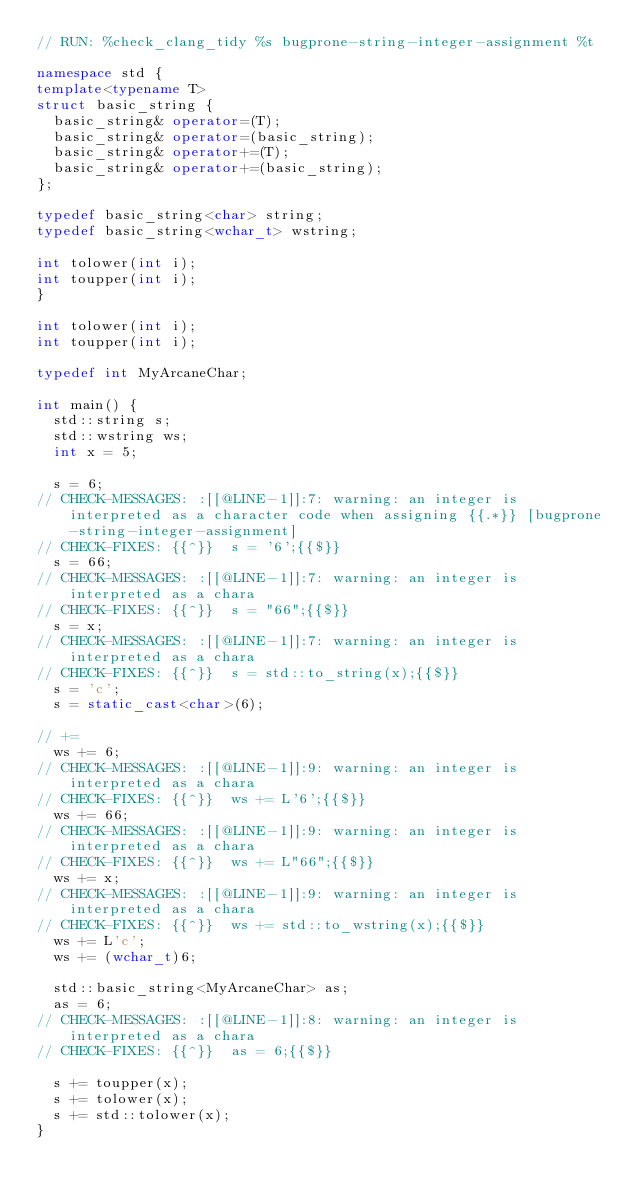Convert code to text. <code><loc_0><loc_0><loc_500><loc_500><_C++_>// RUN: %check_clang_tidy %s bugprone-string-integer-assignment %t

namespace std {
template<typename T>
struct basic_string {
  basic_string& operator=(T);
  basic_string& operator=(basic_string);
  basic_string& operator+=(T);
  basic_string& operator+=(basic_string);
};

typedef basic_string<char> string;
typedef basic_string<wchar_t> wstring;

int tolower(int i);
int toupper(int i);
}

int tolower(int i);
int toupper(int i);

typedef int MyArcaneChar;

int main() {
  std::string s;
  std::wstring ws;
  int x = 5;

  s = 6;
// CHECK-MESSAGES: :[[@LINE-1]]:7: warning: an integer is interpreted as a character code when assigning {{.*}} [bugprone-string-integer-assignment]
// CHECK-FIXES: {{^}}  s = '6';{{$}}
  s = 66;
// CHECK-MESSAGES: :[[@LINE-1]]:7: warning: an integer is interpreted as a chara
// CHECK-FIXES: {{^}}  s = "66";{{$}}
  s = x;
// CHECK-MESSAGES: :[[@LINE-1]]:7: warning: an integer is interpreted as a chara
// CHECK-FIXES: {{^}}  s = std::to_string(x);{{$}}
  s = 'c';
  s = static_cast<char>(6);

// +=
  ws += 6;
// CHECK-MESSAGES: :[[@LINE-1]]:9: warning: an integer is interpreted as a chara
// CHECK-FIXES: {{^}}  ws += L'6';{{$}}
  ws += 66;
// CHECK-MESSAGES: :[[@LINE-1]]:9: warning: an integer is interpreted as a chara
// CHECK-FIXES: {{^}}  ws += L"66";{{$}}
  ws += x;
// CHECK-MESSAGES: :[[@LINE-1]]:9: warning: an integer is interpreted as a chara
// CHECK-FIXES: {{^}}  ws += std::to_wstring(x);{{$}}
  ws += L'c';
  ws += (wchar_t)6;

  std::basic_string<MyArcaneChar> as;
  as = 6;
// CHECK-MESSAGES: :[[@LINE-1]]:8: warning: an integer is interpreted as a chara
// CHECK-FIXES: {{^}}  as = 6;{{$}}

  s += toupper(x);
  s += tolower(x);
  s += std::tolower(x);
}
</code> 